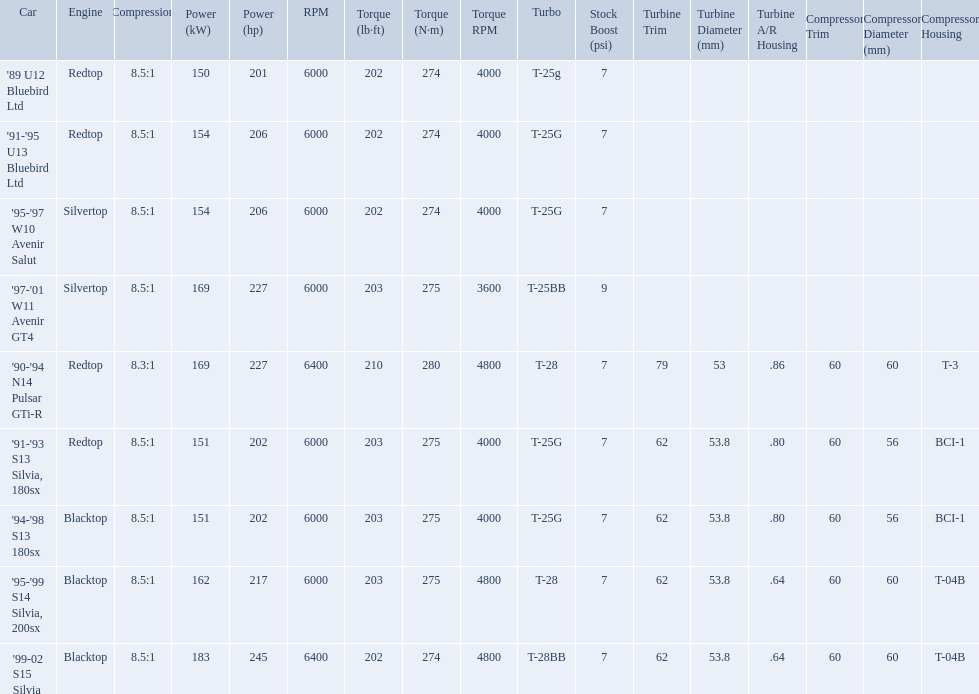What are all the cars? '89 U12 Bluebird Ltd, '91-'95 U13 Bluebird Ltd, '95-'97 W10 Avenir Salut, '97-'01 W11 Avenir GT4, '90-'94 N14 Pulsar GTi-R, '91-'93 S13 Silvia, 180sx, '94-'98 S13 180sx, '95-'99 S14 Silvia, 200sx, '99-02 S15 Silvia. What are their stock boosts? 7psi, 7psi, 7psi, 9psi, 7psi, 7psi, 7psi, 7psi, 7psi. And which car has the highest stock boost? '97-'01 W11 Avenir GT4. 